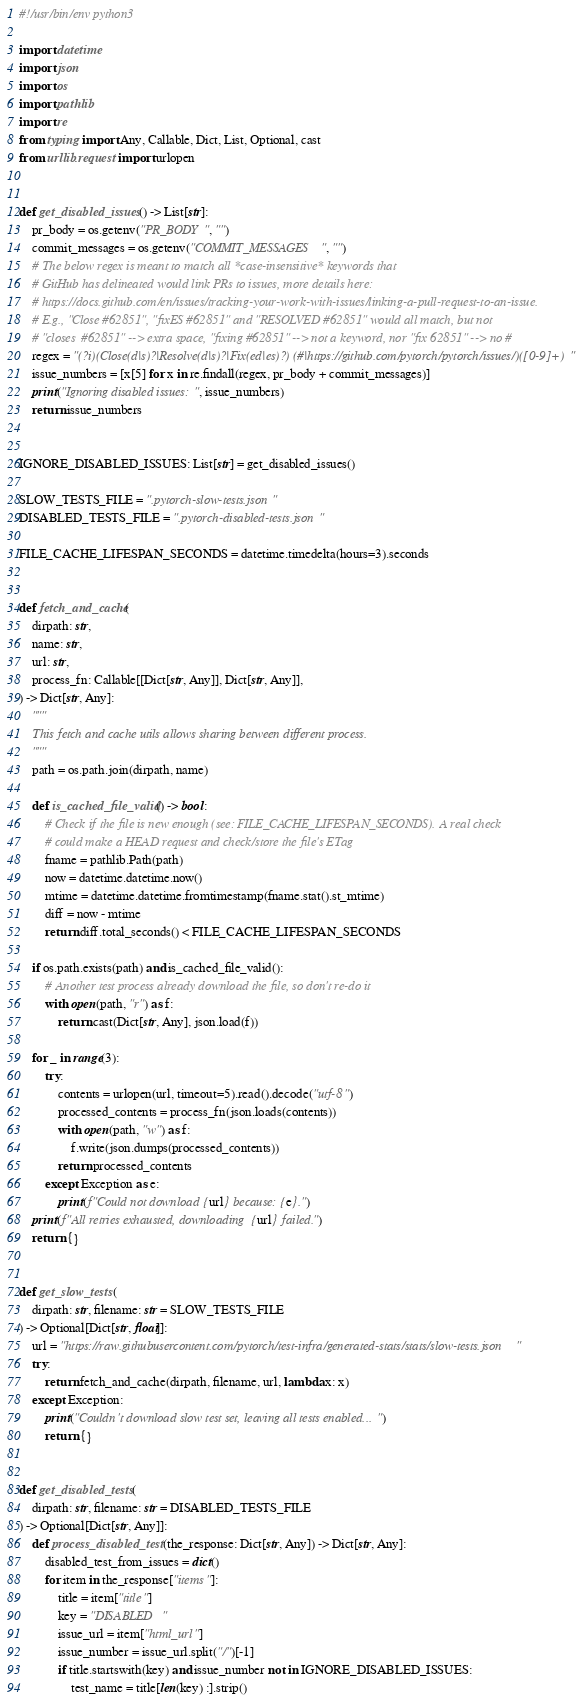<code> <loc_0><loc_0><loc_500><loc_500><_Python_>#!/usr/bin/env python3

import datetime
import json
import os
import pathlib
import re
from typing import Any, Callable, Dict, List, Optional, cast
from urllib.request import urlopen


def get_disabled_issues() -> List[str]:
    pr_body = os.getenv("PR_BODY", "")
    commit_messages = os.getenv("COMMIT_MESSAGES", "")
    # The below regex is meant to match all *case-insensitive* keywords that
    # GitHub has delineated would link PRs to issues, more details here:
    # https://docs.github.com/en/issues/tracking-your-work-with-issues/linking-a-pull-request-to-an-issue.
    # E.g., "Close #62851", "fixES #62851" and "RESOLVED #62851" would all match, but not
    # "closes  #62851" --> extra space, "fixing #62851" --> not a keyword, nor "fix 62851" --> no #
    regex = "(?i)(Close(d|s)?|Resolve(d|s)?|Fix(ed|es)?) (#|https://github.com/pytorch/pytorch/issues/)([0-9]+)"
    issue_numbers = [x[5] for x in re.findall(regex, pr_body + commit_messages)]
    print("Ignoring disabled issues: ", issue_numbers)
    return issue_numbers


IGNORE_DISABLED_ISSUES: List[str] = get_disabled_issues()

SLOW_TESTS_FILE = ".pytorch-slow-tests.json"
DISABLED_TESTS_FILE = ".pytorch-disabled-tests.json"

FILE_CACHE_LIFESPAN_SECONDS = datetime.timedelta(hours=3).seconds


def fetch_and_cache(
    dirpath: str,
    name: str,
    url: str,
    process_fn: Callable[[Dict[str, Any]], Dict[str, Any]],
) -> Dict[str, Any]:
    """
    This fetch and cache utils allows sharing between different process.
    """
    path = os.path.join(dirpath, name)

    def is_cached_file_valid() -> bool:
        # Check if the file is new enough (see: FILE_CACHE_LIFESPAN_SECONDS). A real check
        # could make a HEAD request and check/store the file's ETag
        fname = pathlib.Path(path)
        now = datetime.datetime.now()
        mtime = datetime.datetime.fromtimestamp(fname.stat().st_mtime)
        diff = now - mtime
        return diff.total_seconds() < FILE_CACHE_LIFESPAN_SECONDS

    if os.path.exists(path) and is_cached_file_valid():
        # Another test process already download the file, so don't re-do it
        with open(path, "r") as f:
            return cast(Dict[str, Any], json.load(f))

    for _ in range(3):
        try:
            contents = urlopen(url, timeout=5).read().decode("utf-8")
            processed_contents = process_fn(json.loads(contents))
            with open(path, "w") as f:
                f.write(json.dumps(processed_contents))
            return processed_contents
        except Exception as e:
            print(f"Could not download {url} because: {e}.")
    print(f"All retries exhausted, downloading {url} failed.")
    return {}


def get_slow_tests(
    dirpath: str, filename: str = SLOW_TESTS_FILE
) -> Optional[Dict[str, float]]:
    url = "https://raw.githubusercontent.com/pytorch/test-infra/generated-stats/stats/slow-tests.json"
    try:
        return fetch_and_cache(dirpath, filename, url, lambda x: x)
    except Exception:
        print("Couldn't download slow test set, leaving all tests enabled...")
        return {}


def get_disabled_tests(
    dirpath: str, filename: str = DISABLED_TESTS_FILE
) -> Optional[Dict[str, Any]]:
    def process_disabled_test(the_response: Dict[str, Any]) -> Dict[str, Any]:
        disabled_test_from_issues = dict()
        for item in the_response["items"]:
            title = item["title"]
            key = "DISABLED "
            issue_url = item["html_url"]
            issue_number = issue_url.split("/")[-1]
            if title.startswith(key) and issue_number not in IGNORE_DISABLED_ISSUES:
                test_name = title[len(key) :].strip()</code> 